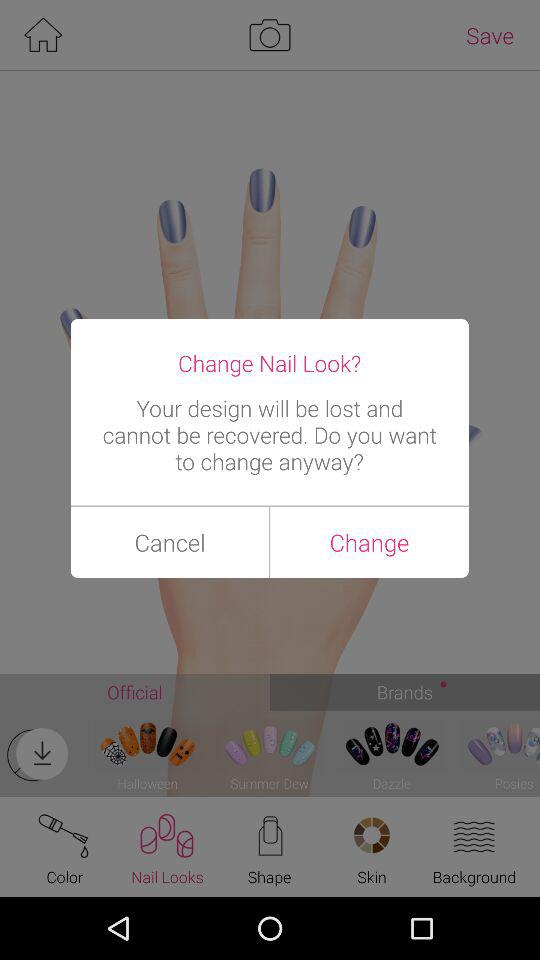What are the available brand names? The available brand names are "Halloween", "Summer Dew", "Dazzle" and "Posies". 